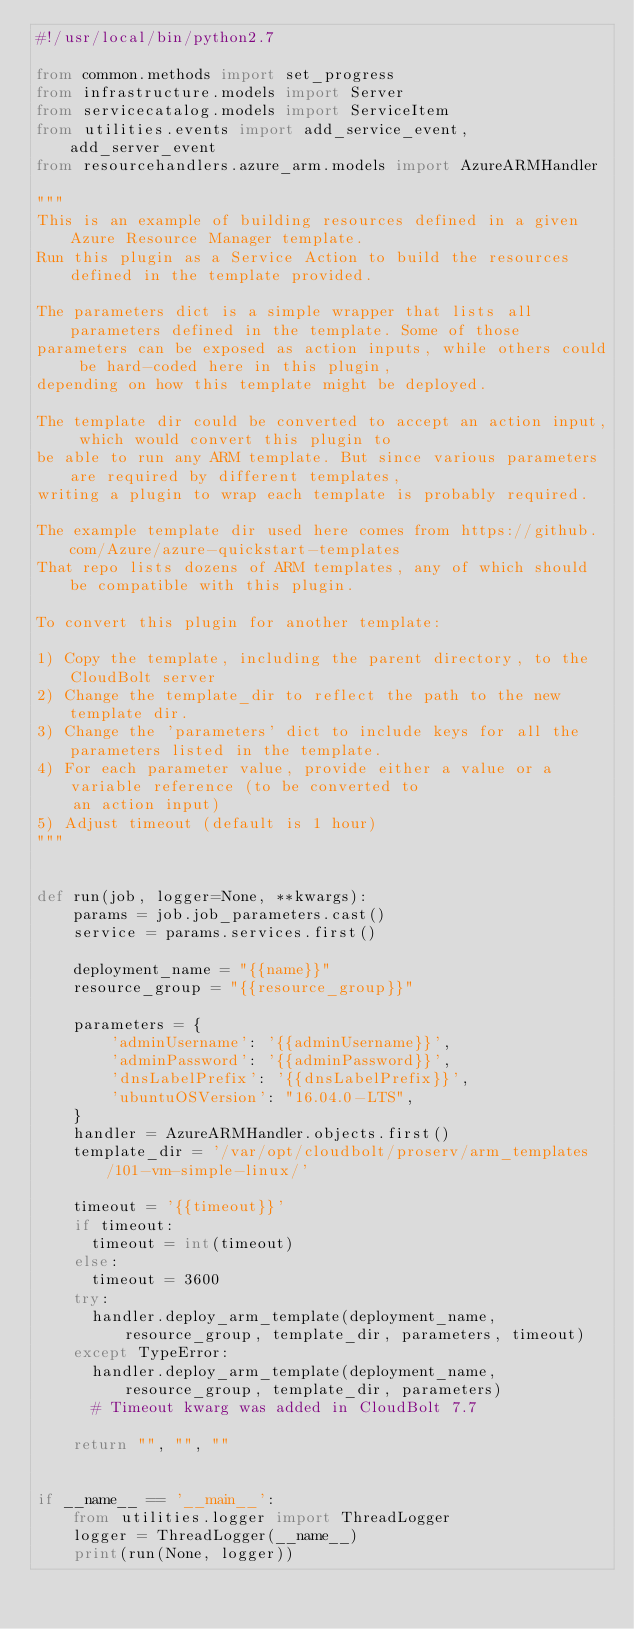Convert code to text. <code><loc_0><loc_0><loc_500><loc_500><_Python_>#!/usr/local/bin/python2.7

from common.methods import set_progress
from infrastructure.models import Server
from servicecatalog.models import ServiceItem
from utilities.events import add_service_event, add_server_event
from resourcehandlers.azure_arm.models import AzureARMHandler

"""
This is an example of building resources defined in a given Azure Resource Manager template.
Run this plugin as a Service Action to build the resources defined in the template provided.

The parameters dict is a simple wrapper that lists all parameters defined in the template. Some of those
parameters can be exposed as action inputs, while others could be hard-coded here in this plugin,
depending on how this template might be deployed.

The template dir could be converted to accept an action input, which would convert this plugin to
be able to run any ARM template. But since various parameters are required by different templates,
writing a plugin to wrap each template is probably required.

The example template dir used here comes from https://github.com/Azure/azure-quickstart-templates
That repo lists dozens of ARM templates, any of which should be compatible with this plugin.

To convert this plugin for another template:

1) Copy the template, including the parent directory, to the CloudBolt server
2) Change the template_dir to reflect the path to the new template dir.
3) Change the 'parameters' dict to include keys for all the parameters listed in the template.
4) For each parameter value, provide either a value or a variable reference (to be converted to
    an action input) 
5) Adjust timeout (default is 1 hour)
"""


def run(job, logger=None, **kwargs):
    params = job.job_parameters.cast()
    service = params.services.first()
    
    deployment_name = "{{name}}"
    resource_group = "{{resource_group}}"
    
    parameters = {
        'adminUsername': '{{adminUsername}}',
        'adminPassword': '{{adminPassword}}',
        'dnsLabelPrefix': '{{dnsLabelPrefix}}',
        'ubuntuOSVersion': "16.04.0-LTS",
    }
    handler = AzureARMHandler.objects.first()
    template_dir = '/var/opt/cloudbolt/proserv/arm_templates/101-vm-simple-linux/'

    timeout = '{{timeout}}'
    if timeout:
      timeout = int(timeout)
    else:
      timeout = 3600
    try:
      handler.deploy_arm_template(deployment_name, resource_group, template_dir, parameters, timeout)
    except TypeError:
      handler.deploy_arm_template(deployment_name, resource_group, template_dir, parameters)
      # Timeout kwarg was added in CloudBolt 7.7    
    
    return "", "", ""


if __name__ == '__main__':
    from utilities.logger import ThreadLogger
    logger = ThreadLogger(__name__)
    print(run(None, logger))</code> 